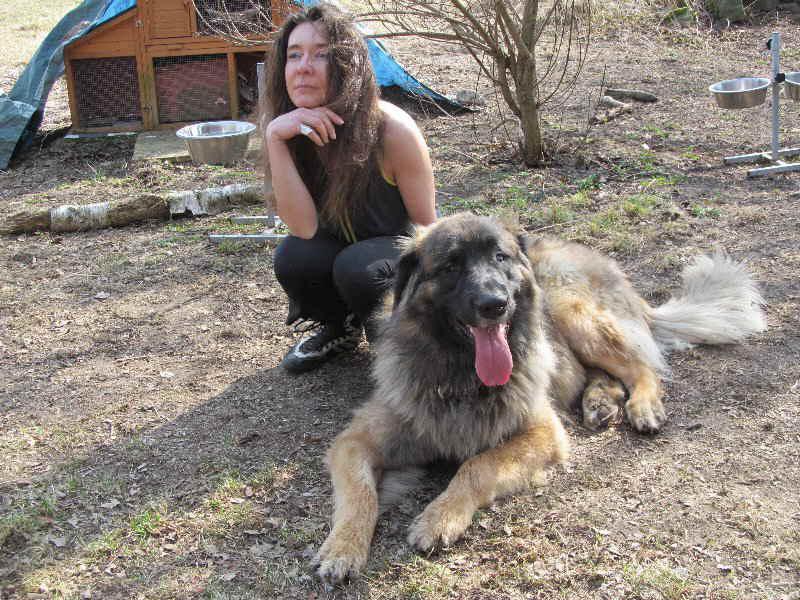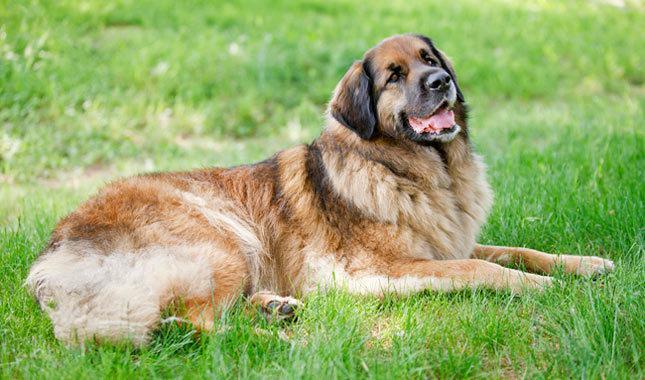The first image is the image on the left, the second image is the image on the right. For the images shown, is this caption "A dog is standing on the grass." true? Answer yes or no. No. The first image is the image on the left, the second image is the image on the right. Given the left and right images, does the statement "An image shows one person to the left of a large dog." hold true? Answer yes or no. Yes. 